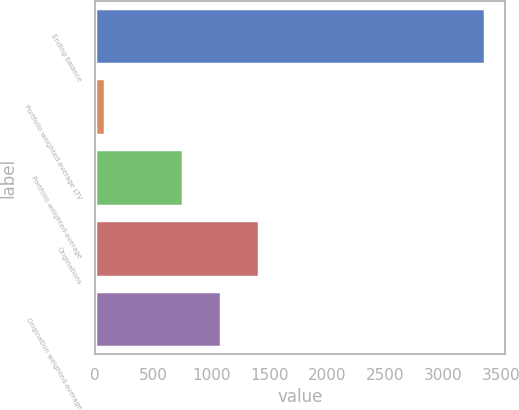Convert chart to OTSL. <chart><loc_0><loc_0><loc_500><loc_500><bar_chart><fcel>Ending balance<fcel>Portfolio weighted-average LTV<fcel>Portfolio weighted-average<fcel>Originations<fcel>Origination weighted-average<nl><fcel>3362<fcel>81<fcel>752<fcel>1408.2<fcel>1080.1<nl></chart> 